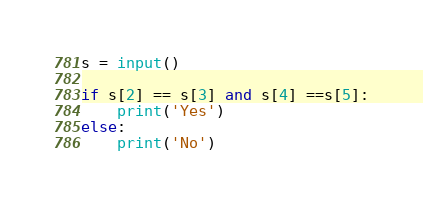<code> <loc_0><loc_0><loc_500><loc_500><_Python_>s = input()

if s[2] == s[3] and s[4] ==s[5]:
    print('Yes')
else:
    print('No')</code> 